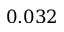Convert formula to latex. <formula><loc_0><loc_0><loc_500><loc_500>0 . 0 3 2</formula> 